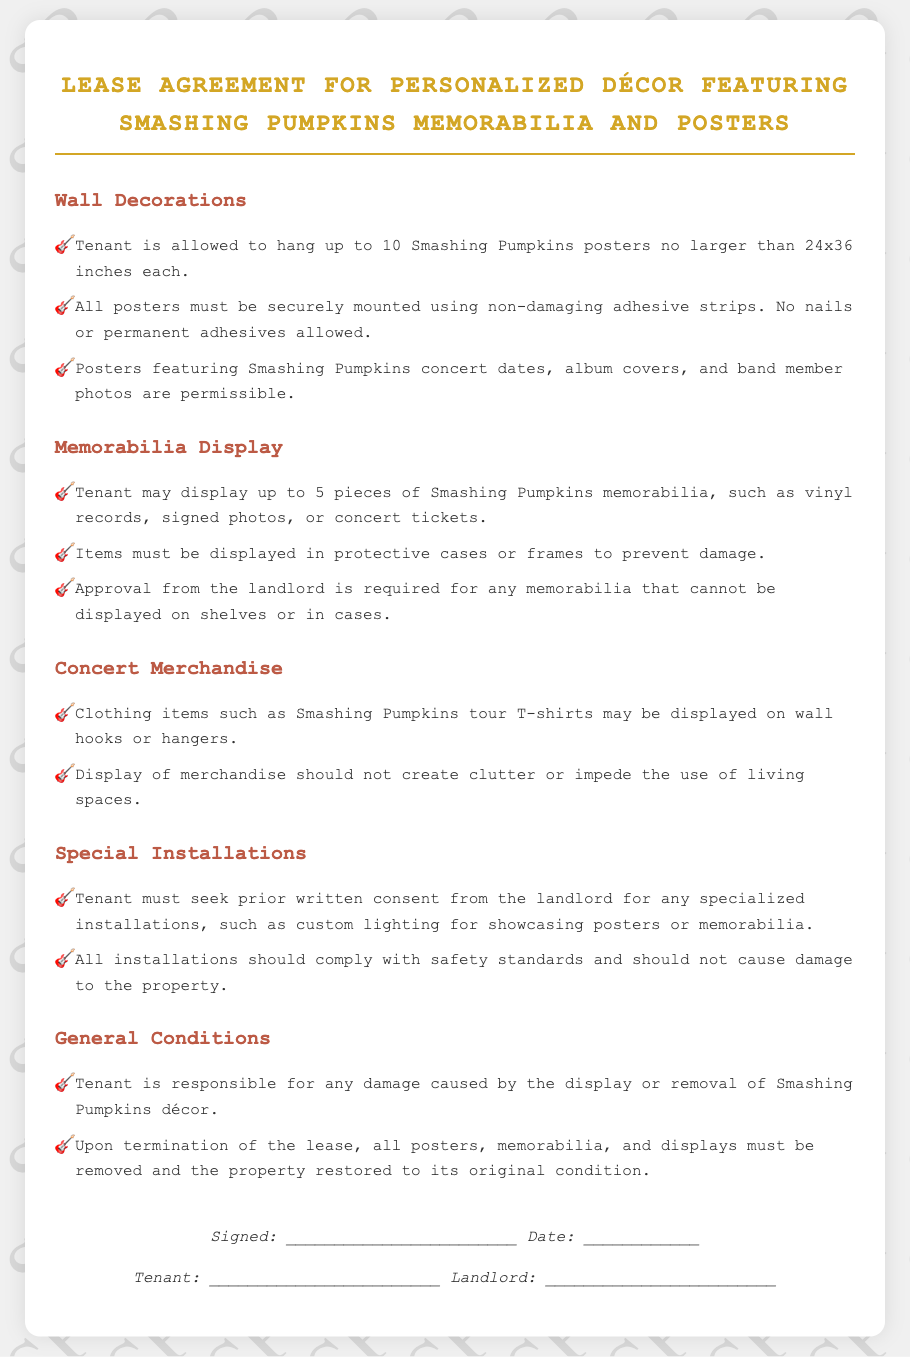What is the maximum number of Smashing Pumpkins posters a tenant can hang? The document states that the tenant is allowed to hang up to 10 posters.
Answer: 10 What size can each poster be? The agreement specifies that posters must not be larger than 24x36 inches.
Answer: 24x36 inches What type of adhesive is permitted for mounting posters? It is mentioned that non-damaging adhesive strips must be used, and nails or permanent adhesives are not allowed.
Answer: Non-damaging adhesive strips How many pieces of memorabilia can a tenant display? The document indicates that the tenant may display up to 5 pieces of memorabilia.
Answer: 5 What must be done with memorabilia that cannot be displayed on shelves or in cases? The landlord's approval is required for such items, according to the agreement.
Answer: Approval from the landlord What is required for any specialized installations? The document states that prior written consent from the landlord must be sought for any specialized installations.
Answer: Prior written consent What must a tenant do upon termination of the lease regarding decorations? The agreement specifies that all decorations must be removed and the property restored to its original condition.
Answer: Remove all decorations What happens if a tenant causes damage from the display of décor? The document states that the tenant is responsible for any damage caused.
Answer: Tenant is responsible What type of items may be displayed on wall hooks or hangers? Clothing items such as Smashing Pumpkins tour T-shirts may be displayed on wall hooks or hangers.
Answer: Smashing Pumpkins tour T-shirts 